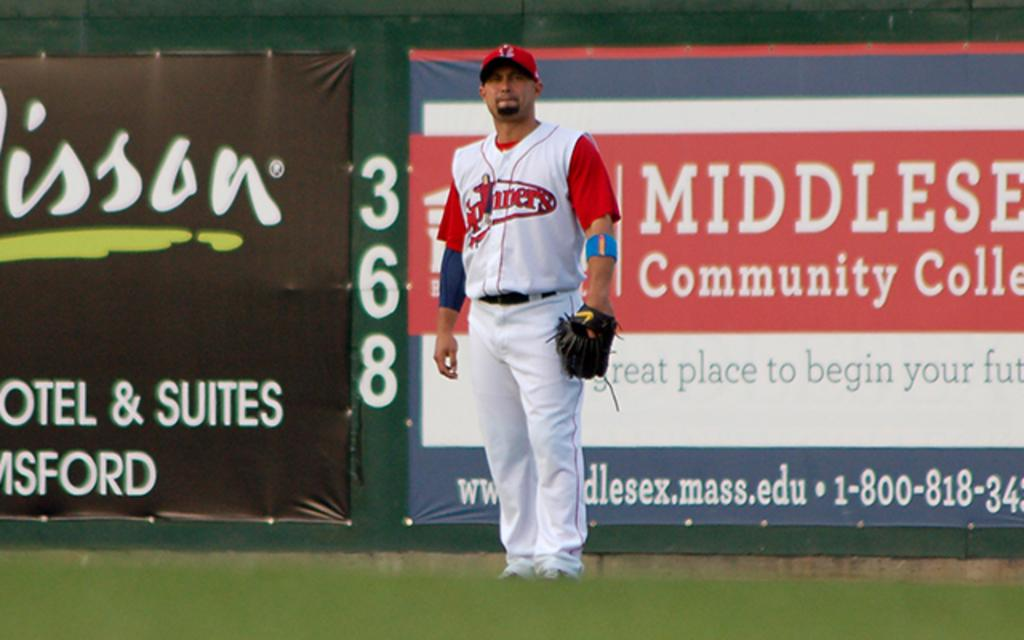<image>
Present a compact description of the photo's key features. Baseball player standing in front of an ad for a Community College. 